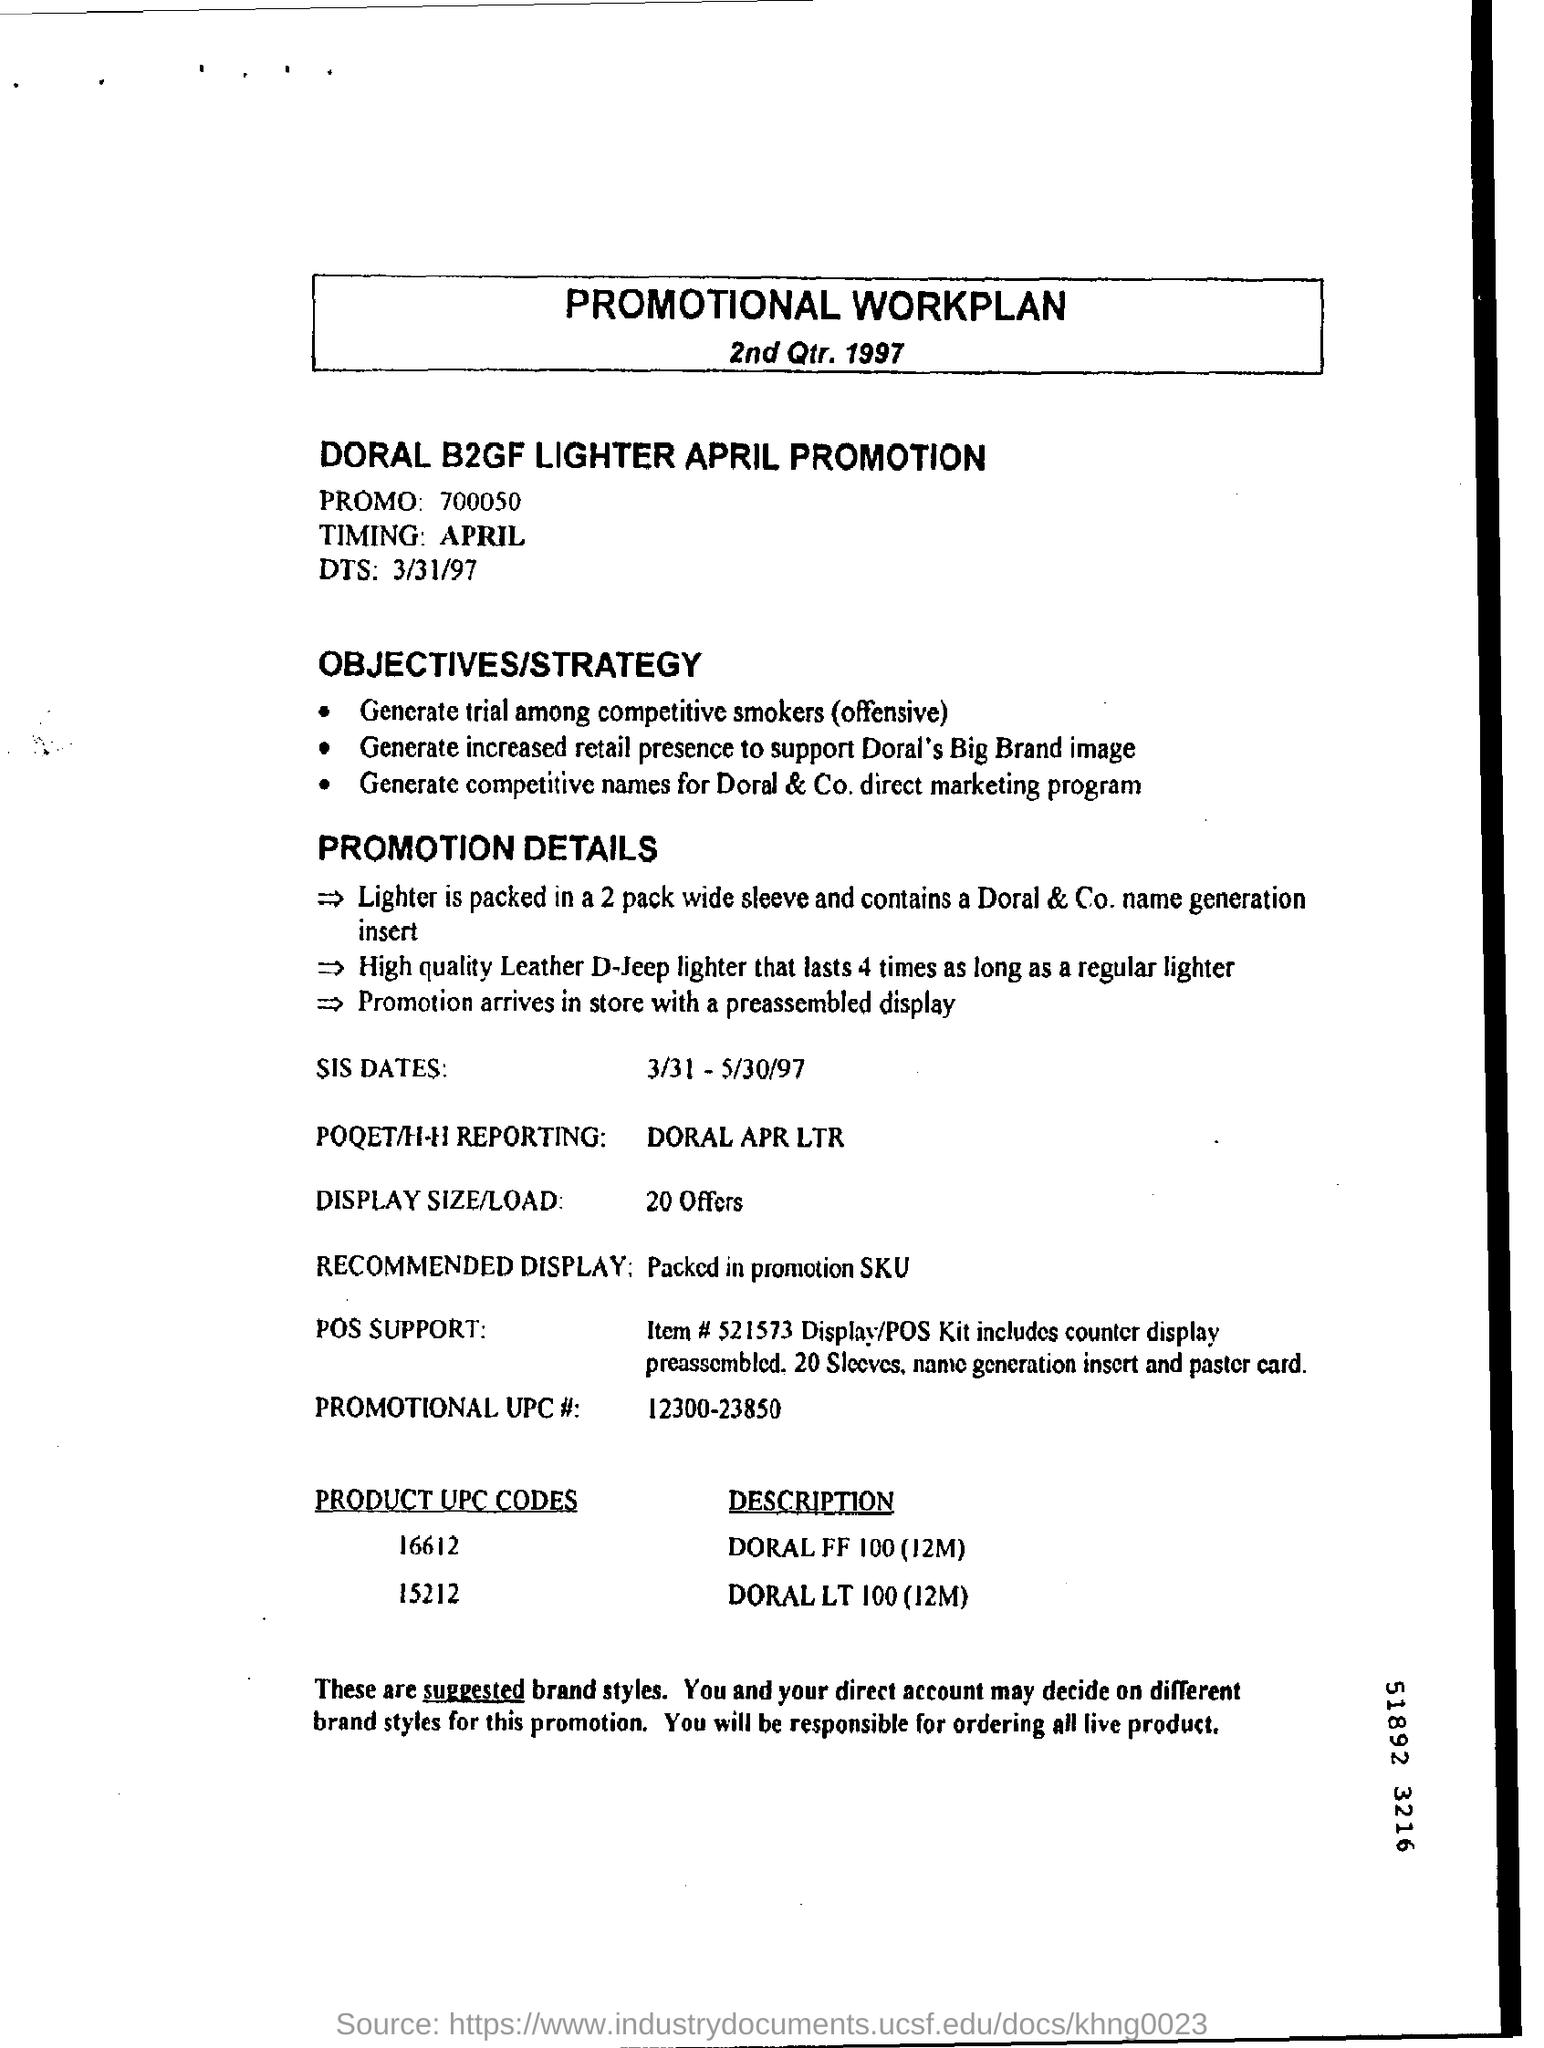What is "timing" mentioned?
 april 